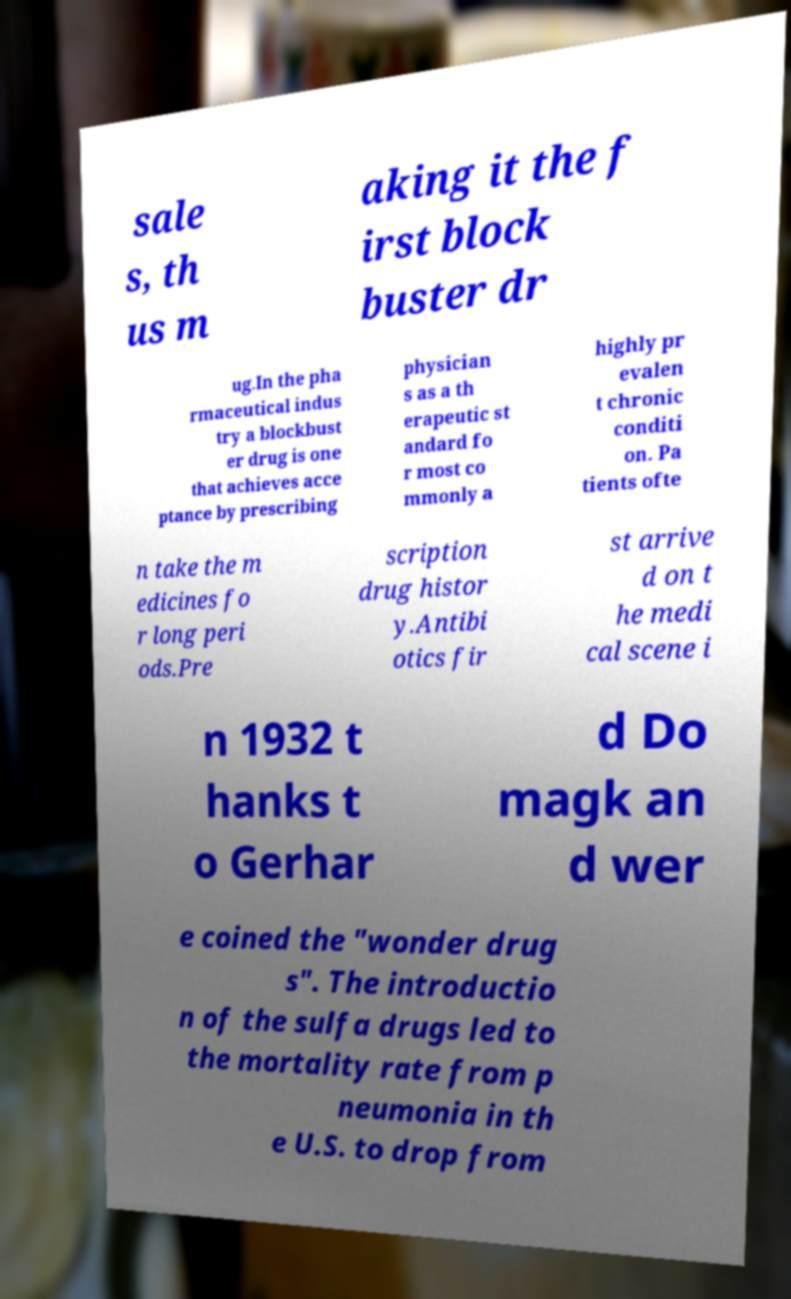Please read and relay the text visible in this image. What does it say? sale s, th us m aking it the f irst block buster dr ug.In the pha rmaceutical indus try a blockbust er drug is one that achieves acce ptance by prescribing physician s as a th erapeutic st andard fo r most co mmonly a highly pr evalen t chronic conditi on. Pa tients ofte n take the m edicines fo r long peri ods.Pre scription drug histor y.Antibi otics fir st arrive d on t he medi cal scene i n 1932 t hanks t o Gerhar d Do magk an d wer e coined the "wonder drug s". The introductio n of the sulfa drugs led to the mortality rate from p neumonia in th e U.S. to drop from 